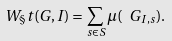Convert formula to latex. <formula><loc_0><loc_0><loc_500><loc_500>W _ { \S } t ( G , I ) = \sum _ { s \in S } \mu ( \ G _ { I , s } ) .</formula> 